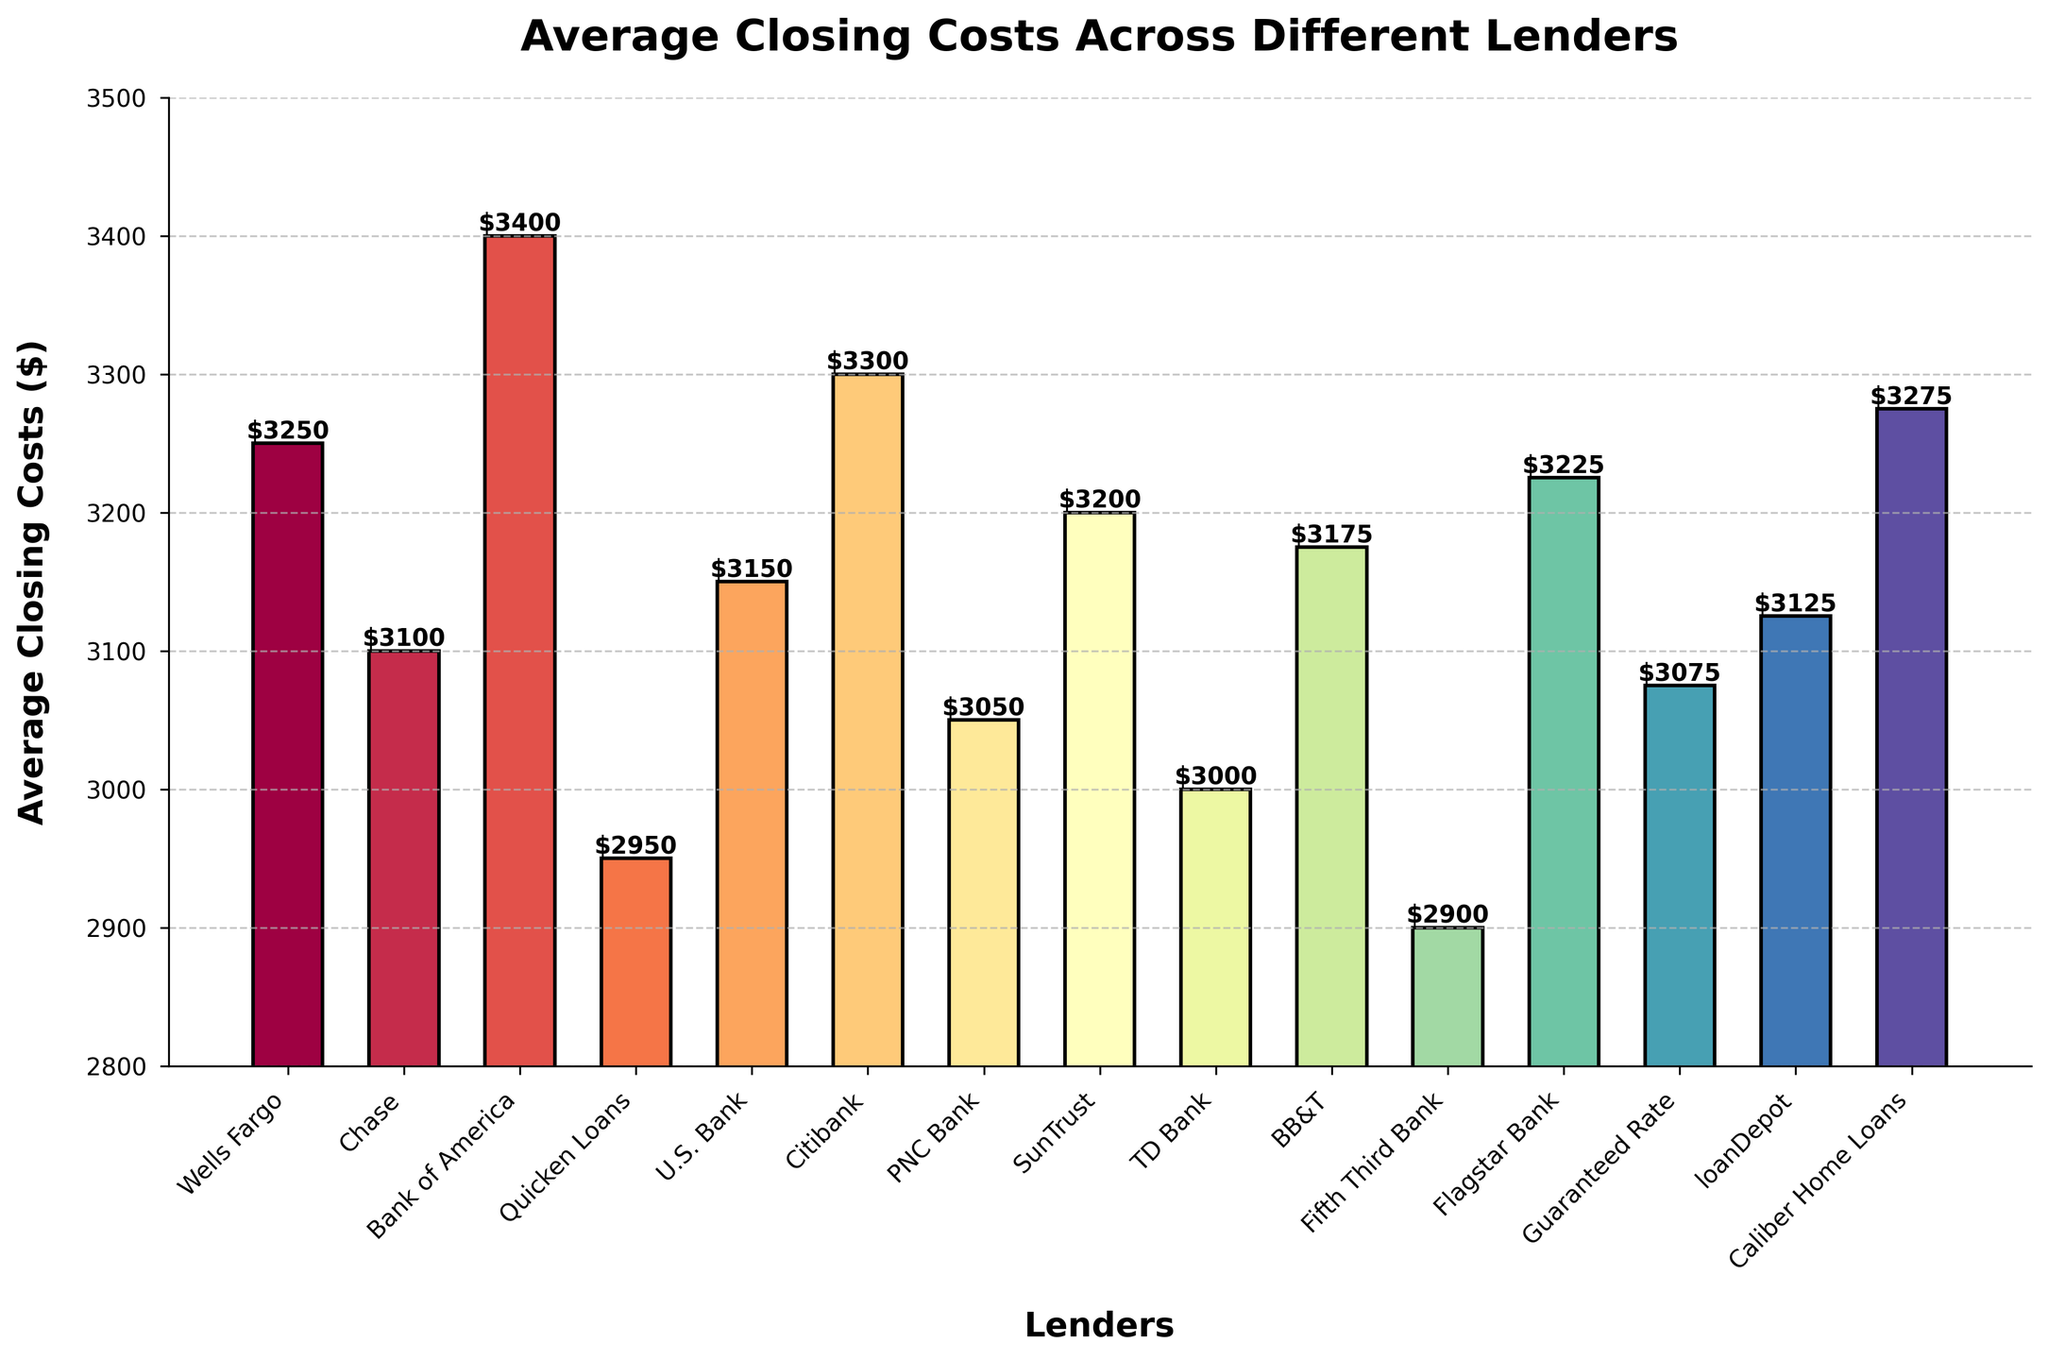Which lender has the lowest average closing costs? Look at the bar height to find the lowest value. Quicken Loans is the shortest bar, indicating it has the lowest average closing costs at $2950.
Answer: Quicken Loans Which lender has the highest average closing costs? Look at the bar height to find the highest value. Bank of America is the tallest bar, indicating it has the highest average closing costs at $3400.
Answer: Bank of America What is the difference in average closing costs between Chase and Citibank? Find the heights of the bars for Chase ($3100) and Citibank ($3300). Subtract the lower value from the higher value: $3300 - $3100.
Answer: $200 How many lenders have average closing costs higher than $3200? Count the bars that are above the $3200 mark: Wells Fargo, Bank of America, Citibank, SunTrust, Flagstar Bank, Caliber Home Loans. There are 6 lenders.
Answer: 6 Is the average closing cost of TD Bank closer to PNC Bank or Fifth Third Bank? Find the heights of the bars for TD Bank ($3000), PNC Bank ($3050), and Fifth Third Bank ($2900). Calculate the distance: TD Bank to PNC Bank = $3050 - $3000 = $50; TD Bank to Fifth Third Bank = $3000 - $2900 = $100. TD Bank is closer to PNC Bank.
Answer: PNC Bank Which two lenders have the same average closing costs? Look for bars that have the same height. There are no lenders with exactly the same average closing costs.
Answer: None What is the total closing cost if a buyer considers Guaranteed Rate and loanDepot? Add the average closing costs of Guaranteed Rate ($3075) and loanDepot ($3125): $3075 + $3125 = $6200.
Answer: $6200 Which lender's average closing cost is closest to the median value of all lenders' average closing costs? List all costs and find the median: $2900 (Fifth Third Bank), $2950 (Quicken Loans), $3000 (TD Bank), $3050 (PNC Bank), $3075 (Guaranteed Rate), $3100 (Chase), $3125 (loanDepot), $3150 (U.S. Bank), $3175 (BB&T), $3200 (SunTrust), $3225 (Flagstar Bank), $3250 (Wells Fargo), $3275 (Caliber Home Loans), $3300 (Citibank), $3400 (Bank of America). Median is $3150 (U.S. Bank).
Answer: U.S. Bank 